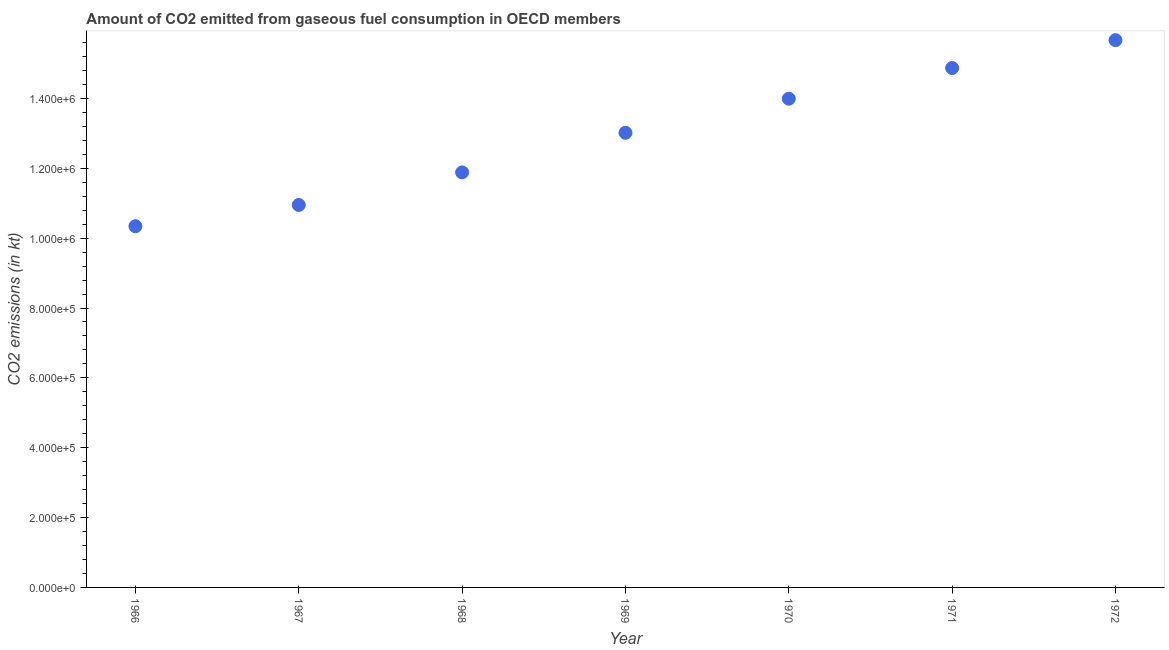What is the co2 emissions from gaseous fuel consumption in 1967?
Ensure brevity in your answer.  1.10e+06. Across all years, what is the maximum co2 emissions from gaseous fuel consumption?
Provide a short and direct response. 1.57e+06. Across all years, what is the minimum co2 emissions from gaseous fuel consumption?
Your response must be concise. 1.03e+06. In which year was the co2 emissions from gaseous fuel consumption maximum?
Make the answer very short. 1972. In which year was the co2 emissions from gaseous fuel consumption minimum?
Your answer should be compact. 1966. What is the sum of the co2 emissions from gaseous fuel consumption?
Give a very brief answer. 9.07e+06. What is the difference between the co2 emissions from gaseous fuel consumption in 1969 and 1971?
Ensure brevity in your answer.  -1.85e+05. What is the average co2 emissions from gaseous fuel consumption per year?
Ensure brevity in your answer.  1.30e+06. What is the median co2 emissions from gaseous fuel consumption?
Provide a short and direct response. 1.30e+06. In how many years, is the co2 emissions from gaseous fuel consumption greater than 80000 kt?
Make the answer very short. 7. What is the ratio of the co2 emissions from gaseous fuel consumption in 1966 to that in 1967?
Keep it short and to the point. 0.94. Is the difference between the co2 emissions from gaseous fuel consumption in 1967 and 1970 greater than the difference between any two years?
Your answer should be compact. No. What is the difference between the highest and the second highest co2 emissions from gaseous fuel consumption?
Your response must be concise. 7.98e+04. Is the sum of the co2 emissions from gaseous fuel consumption in 1967 and 1971 greater than the maximum co2 emissions from gaseous fuel consumption across all years?
Offer a terse response. Yes. What is the difference between the highest and the lowest co2 emissions from gaseous fuel consumption?
Provide a short and direct response. 5.33e+05. Does the co2 emissions from gaseous fuel consumption monotonically increase over the years?
Keep it short and to the point. Yes. How many years are there in the graph?
Keep it short and to the point. 7. What is the difference between two consecutive major ticks on the Y-axis?
Provide a succinct answer. 2.00e+05. Are the values on the major ticks of Y-axis written in scientific E-notation?
Offer a very short reply. Yes. What is the title of the graph?
Make the answer very short. Amount of CO2 emitted from gaseous fuel consumption in OECD members. What is the label or title of the X-axis?
Provide a succinct answer. Year. What is the label or title of the Y-axis?
Offer a terse response. CO2 emissions (in kt). What is the CO2 emissions (in kt) in 1966?
Your response must be concise. 1.03e+06. What is the CO2 emissions (in kt) in 1967?
Make the answer very short. 1.10e+06. What is the CO2 emissions (in kt) in 1968?
Give a very brief answer. 1.19e+06. What is the CO2 emissions (in kt) in 1969?
Give a very brief answer. 1.30e+06. What is the CO2 emissions (in kt) in 1970?
Give a very brief answer. 1.40e+06. What is the CO2 emissions (in kt) in 1971?
Make the answer very short. 1.49e+06. What is the CO2 emissions (in kt) in 1972?
Give a very brief answer. 1.57e+06. What is the difference between the CO2 emissions (in kt) in 1966 and 1967?
Offer a very short reply. -6.08e+04. What is the difference between the CO2 emissions (in kt) in 1966 and 1968?
Give a very brief answer. -1.54e+05. What is the difference between the CO2 emissions (in kt) in 1966 and 1969?
Provide a succinct answer. -2.68e+05. What is the difference between the CO2 emissions (in kt) in 1966 and 1970?
Ensure brevity in your answer.  -3.65e+05. What is the difference between the CO2 emissions (in kt) in 1966 and 1971?
Offer a terse response. -4.53e+05. What is the difference between the CO2 emissions (in kt) in 1966 and 1972?
Your answer should be very brief. -5.33e+05. What is the difference between the CO2 emissions (in kt) in 1967 and 1968?
Your answer should be very brief. -9.33e+04. What is the difference between the CO2 emissions (in kt) in 1967 and 1969?
Offer a very short reply. -2.07e+05. What is the difference between the CO2 emissions (in kt) in 1967 and 1970?
Ensure brevity in your answer.  -3.04e+05. What is the difference between the CO2 emissions (in kt) in 1967 and 1971?
Your answer should be compact. -3.92e+05. What is the difference between the CO2 emissions (in kt) in 1967 and 1972?
Make the answer very short. -4.72e+05. What is the difference between the CO2 emissions (in kt) in 1968 and 1969?
Give a very brief answer. -1.13e+05. What is the difference between the CO2 emissions (in kt) in 1968 and 1970?
Your answer should be very brief. -2.11e+05. What is the difference between the CO2 emissions (in kt) in 1968 and 1971?
Offer a very short reply. -2.99e+05. What is the difference between the CO2 emissions (in kt) in 1968 and 1972?
Provide a succinct answer. -3.79e+05. What is the difference between the CO2 emissions (in kt) in 1969 and 1970?
Your response must be concise. -9.76e+04. What is the difference between the CO2 emissions (in kt) in 1969 and 1971?
Your answer should be very brief. -1.85e+05. What is the difference between the CO2 emissions (in kt) in 1969 and 1972?
Make the answer very short. -2.65e+05. What is the difference between the CO2 emissions (in kt) in 1970 and 1971?
Ensure brevity in your answer.  -8.78e+04. What is the difference between the CO2 emissions (in kt) in 1970 and 1972?
Give a very brief answer. -1.68e+05. What is the difference between the CO2 emissions (in kt) in 1971 and 1972?
Your response must be concise. -7.98e+04. What is the ratio of the CO2 emissions (in kt) in 1966 to that in 1967?
Your answer should be very brief. 0.94. What is the ratio of the CO2 emissions (in kt) in 1966 to that in 1968?
Give a very brief answer. 0.87. What is the ratio of the CO2 emissions (in kt) in 1966 to that in 1969?
Provide a succinct answer. 0.79. What is the ratio of the CO2 emissions (in kt) in 1966 to that in 1970?
Offer a terse response. 0.74. What is the ratio of the CO2 emissions (in kt) in 1966 to that in 1971?
Your answer should be very brief. 0.69. What is the ratio of the CO2 emissions (in kt) in 1966 to that in 1972?
Your response must be concise. 0.66. What is the ratio of the CO2 emissions (in kt) in 1967 to that in 1968?
Your answer should be very brief. 0.92. What is the ratio of the CO2 emissions (in kt) in 1967 to that in 1969?
Offer a very short reply. 0.84. What is the ratio of the CO2 emissions (in kt) in 1967 to that in 1970?
Make the answer very short. 0.78. What is the ratio of the CO2 emissions (in kt) in 1967 to that in 1971?
Keep it short and to the point. 0.74. What is the ratio of the CO2 emissions (in kt) in 1967 to that in 1972?
Your answer should be very brief. 0.7. What is the ratio of the CO2 emissions (in kt) in 1968 to that in 1969?
Ensure brevity in your answer.  0.91. What is the ratio of the CO2 emissions (in kt) in 1968 to that in 1970?
Provide a succinct answer. 0.85. What is the ratio of the CO2 emissions (in kt) in 1968 to that in 1971?
Offer a very short reply. 0.8. What is the ratio of the CO2 emissions (in kt) in 1968 to that in 1972?
Ensure brevity in your answer.  0.76. What is the ratio of the CO2 emissions (in kt) in 1969 to that in 1970?
Provide a short and direct response. 0.93. What is the ratio of the CO2 emissions (in kt) in 1969 to that in 1971?
Offer a very short reply. 0.88. What is the ratio of the CO2 emissions (in kt) in 1969 to that in 1972?
Make the answer very short. 0.83. What is the ratio of the CO2 emissions (in kt) in 1970 to that in 1971?
Keep it short and to the point. 0.94. What is the ratio of the CO2 emissions (in kt) in 1970 to that in 1972?
Keep it short and to the point. 0.89. What is the ratio of the CO2 emissions (in kt) in 1971 to that in 1972?
Your response must be concise. 0.95. 